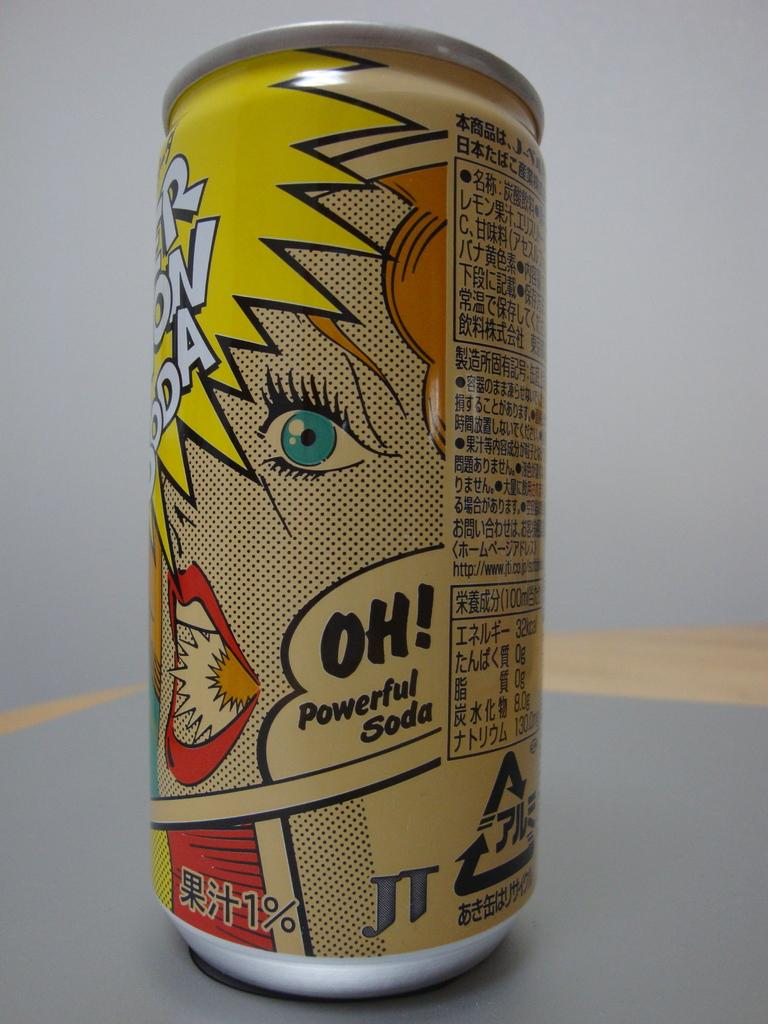<image>
Create a compact narrative representing the image presented. A can of soda says "Oh! Powerful Soda" on the label. 